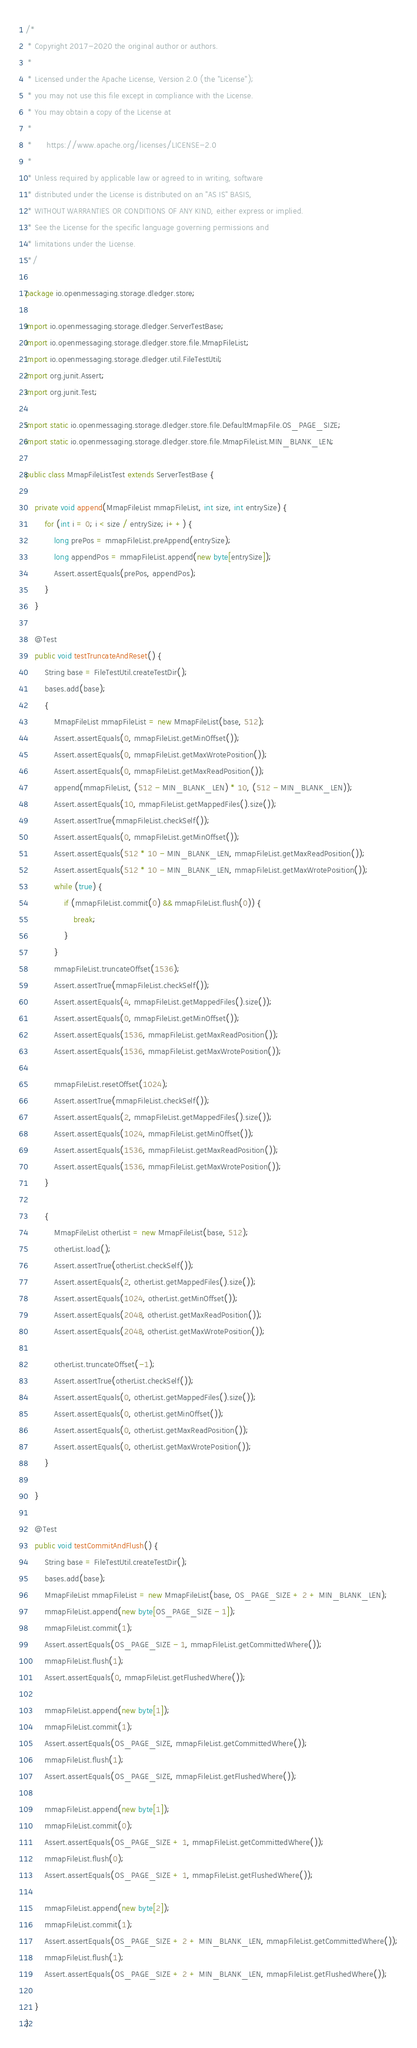Convert code to text. <code><loc_0><loc_0><loc_500><loc_500><_Java_>/*
 * Copyright 2017-2020 the original author or authors.
 *
 * Licensed under the Apache License, Version 2.0 (the "License");
 * you may not use this file except in compliance with the License.
 * You may obtain a copy of the License at
 *
 *      https://www.apache.org/licenses/LICENSE-2.0
 *
 * Unless required by applicable law or agreed to in writing, software
 * distributed under the License is distributed on an "AS IS" BASIS,
 * WITHOUT WARRANTIES OR CONDITIONS OF ANY KIND, either express or implied.
 * See the License for the specific language governing permissions and
 * limitations under the License.
 */

package io.openmessaging.storage.dledger.store;

import io.openmessaging.storage.dledger.ServerTestBase;
import io.openmessaging.storage.dledger.store.file.MmapFileList;
import io.openmessaging.storage.dledger.util.FileTestUtil;
import org.junit.Assert;
import org.junit.Test;

import static io.openmessaging.storage.dledger.store.file.DefaultMmapFile.OS_PAGE_SIZE;
import static io.openmessaging.storage.dledger.store.file.MmapFileList.MIN_BLANK_LEN;

public class MmapFileListTest extends ServerTestBase {

    private void append(MmapFileList mmapFileList, int size, int entrySize) {
        for (int i = 0; i < size / entrySize; i++) {
            long prePos = mmapFileList.preAppend(entrySize);
            long appendPos = mmapFileList.append(new byte[entrySize]);
            Assert.assertEquals(prePos, appendPos);
        }
    }

    @Test
    public void testTruncateAndReset() {
        String base = FileTestUtil.createTestDir();
        bases.add(base);
        {
            MmapFileList mmapFileList = new MmapFileList(base, 512);
            Assert.assertEquals(0, mmapFileList.getMinOffset());
            Assert.assertEquals(0, mmapFileList.getMaxWrotePosition());
            Assert.assertEquals(0, mmapFileList.getMaxReadPosition());
            append(mmapFileList, (512 - MIN_BLANK_LEN) * 10, (512 - MIN_BLANK_LEN));
            Assert.assertEquals(10, mmapFileList.getMappedFiles().size());
            Assert.assertTrue(mmapFileList.checkSelf());
            Assert.assertEquals(0, mmapFileList.getMinOffset());
            Assert.assertEquals(512 * 10 - MIN_BLANK_LEN, mmapFileList.getMaxReadPosition());
            Assert.assertEquals(512 * 10 - MIN_BLANK_LEN, mmapFileList.getMaxWrotePosition());
            while (true) {
                if (mmapFileList.commit(0) && mmapFileList.flush(0)) {
                    break;
                }
            }
            mmapFileList.truncateOffset(1536);
            Assert.assertTrue(mmapFileList.checkSelf());
            Assert.assertEquals(4, mmapFileList.getMappedFiles().size());
            Assert.assertEquals(0, mmapFileList.getMinOffset());
            Assert.assertEquals(1536, mmapFileList.getMaxReadPosition());
            Assert.assertEquals(1536, mmapFileList.getMaxWrotePosition());

            mmapFileList.resetOffset(1024);
            Assert.assertTrue(mmapFileList.checkSelf());
            Assert.assertEquals(2, mmapFileList.getMappedFiles().size());
            Assert.assertEquals(1024, mmapFileList.getMinOffset());
            Assert.assertEquals(1536, mmapFileList.getMaxReadPosition());
            Assert.assertEquals(1536, mmapFileList.getMaxWrotePosition());
        }

        {
            MmapFileList otherList = new MmapFileList(base, 512);
            otherList.load();
            Assert.assertTrue(otherList.checkSelf());
            Assert.assertEquals(2, otherList.getMappedFiles().size());
            Assert.assertEquals(1024, otherList.getMinOffset());
            Assert.assertEquals(2048, otherList.getMaxReadPosition());
            Assert.assertEquals(2048, otherList.getMaxWrotePosition());

            otherList.truncateOffset(-1);
            Assert.assertTrue(otherList.checkSelf());
            Assert.assertEquals(0, otherList.getMappedFiles().size());
            Assert.assertEquals(0, otherList.getMinOffset());
            Assert.assertEquals(0, otherList.getMaxReadPosition());
            Assert.assertEquals(0, otherList.getMaxWrotePosition());
        }

    }

    @Test
    public void testCommitAndFlush() {
        String base = FileTestUtil.createTestDir();
        bases.add(base);
        MmapFileList mmapFileList = new MmapFileList(base, OS_PAGE_SIZE + 2 + MIN_BLANK_LEN);
        mmapFileList.append(new byte[OS_PAGE_SIZE - 1]);
        mmapFileList.commit(1);
        Assert.assertEquals(OS_PAGE_SIZE - 1, mmapFileList.getCommittedWhere());
        mmapFileList.flush(1);
        Assert.assertEquals(0, mmapFileList.getFlushedWhere());

        mmapFileList.append(new byte[1]);
        mmapFileList.commit(1);
        Assert.assertEquals(OS_PAGE_SIZE, mmapFileList.getCommittedWhere());
        mmapFileList.flush(1);
        Assert.assertEquals(OS_PAGE_SIZE, mmapFileList.getFlushedWhere());

        mmapFileList.append(new byte[1]);
        mmapFileList.commit(0);
        Assert.assertEquals(OS_PAGE_SIZE + 1, mmapFileList.getCommittedWhere());
        mmapFileList.flush(0);
        Assert.assertEquals(OS_PAGE_SIZE + 1, mmapFileList.getFlushedWhere());

        mmapFileList.append(new byte[2]);
        mmapFileList.commit(1);
        Assert.assertEquals(OS_PAGE_SIZE + 2 + MIN_BLANK_LEN, mmapFileList.getCommittedWhere());
        mmapFileList.flush(1);
        Assert.assertEquals(OS_PAGE_SIZE + 2 + MIN_BLANK_LEN, mmapFileList.getFlushedWhere());

    }
}
</code> 